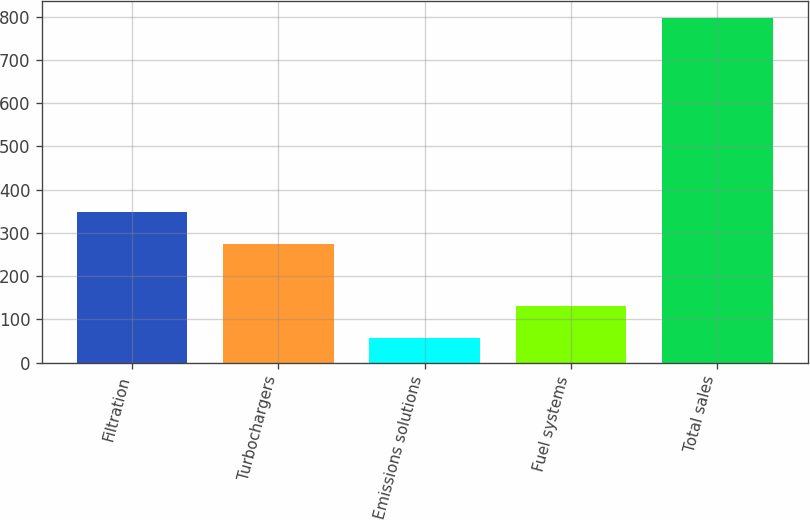Convert chart. <chart><loc_0><loc_0><loc_500><loc_500><bar_chart><fcel>Filtration<fcel>Turbochargers<fcel>Emissions solutions<fcel>Fuel systems<fcel>Total sales<nl><fcel>348.9<fcel>275<fcel>58<fcel>131.9<fcel>797<nl></chart> 